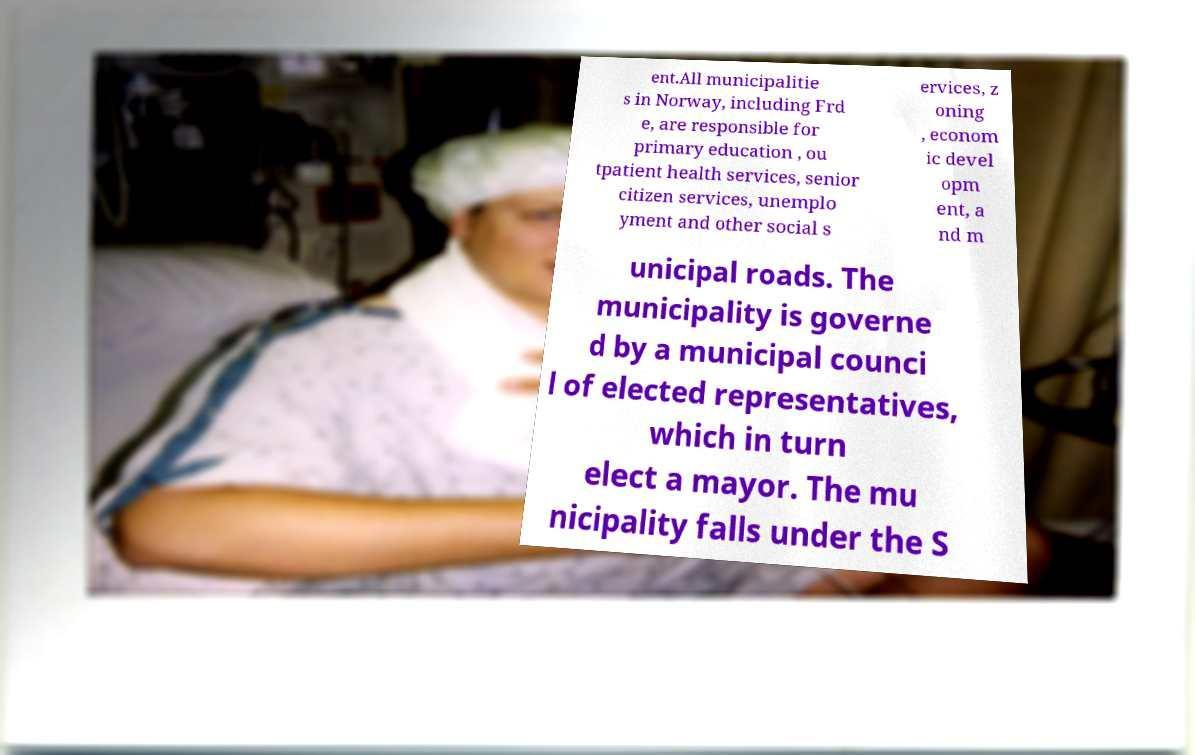Can you accurately transcribe the text from the provided image for me? ent.All municipalitie s in Norway, including Frd e, are responsible for primary education , ou tpatient health services, senior citizen services, unemplo yment and other social s ervices, z oning , econom ic devel opm ent, a nd m unicipal roads. The municipality is governe d by a municipal counci l of elected representatives, which in turn elect a mayor. The mu nicipality falls under the S 